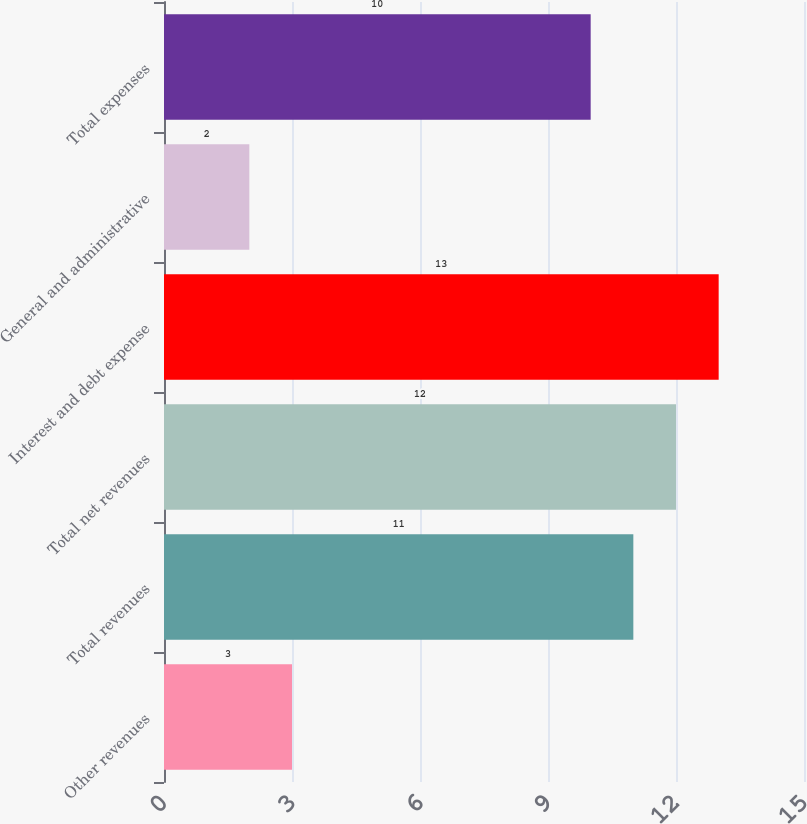Convert chart to OTSL. <chart><loc_0><loc_0><loc_500><loc_500><bar_chart><fcel>Other revenues<fcel>Total revenues<fcel>Total net revenues<fcel>Interest and debt expense<fcel>General and administrative<fcel>Total expenses<nl><fcel>3<fcel>11<fcel>12<fcel>13<fcel>2<fcel>10<nl></chart> 